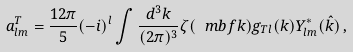<formula> <loc_0><loc_0><loc_500><loc_500>a ^ { T } _ { l m } = \frac { 1 2 \pi } { 5 } ( - i ) ^ { l } \int \frac { d ^ { 3 } k } { ( 2 \pi ) ^ { 3 } } \zeta ( \ m b f k ) g _ { T l } ( k ) Y ^ { \ast } _ { l m } ( \hat { k } ) \, ,</formula> 